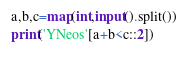Convert code to text. <code><loc_0><loc_0><loc_500><loc_500><_Python_>a,b,c=map(int,input().split())
print('YNeos'[a+b<c::2])</code> 